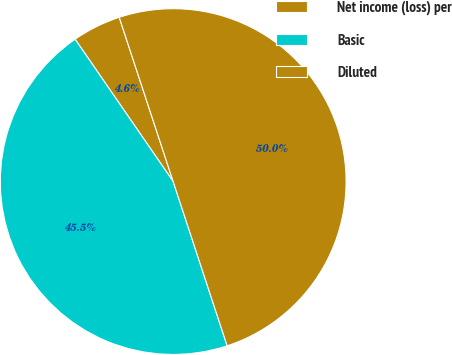Convert chart. <chart><loc_0><loc_0><loc_500><loc_500><pie_chart><fcel>Net income (loss) per<fcel>Basic<fcel>Diluted<nl><fcel>4.55%<fcel>45.45%<fcel>50.0%<nl></chart> 